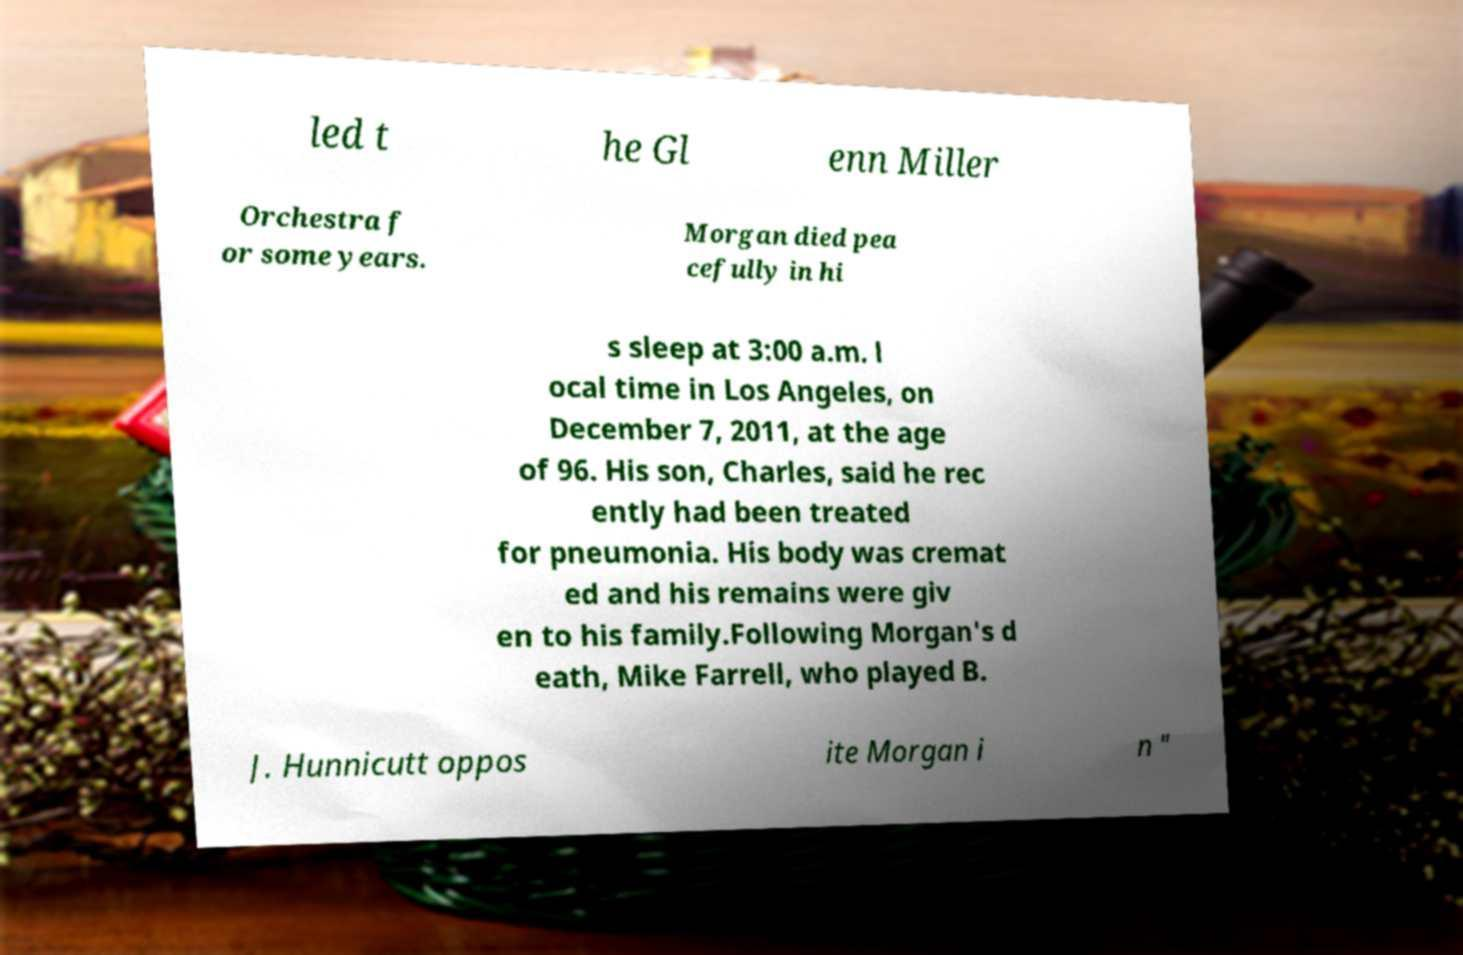Can you read and provide the text displayed in the image?This photo seems to have some interesting text. Can you extract and type it out for me? led t he Gl enn Miller Orchestra f or some years. Morgan died pea cefully in hi s sleep at 3:00 a.m. l ocal time in Los Angeles, on December 7, 2011, at the age of 96. His son, Charles, said he rec ently had been treated for pneumonia. His body was cremat ed and his remains were giv en to his family.Following Morgan's d eath, Mike Farrell, who played B. J. Hunnicutt oppos ite Morgan i n " 